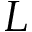<formula> <loc_0><loc_0><loc_500><loc_500>L</formula> 